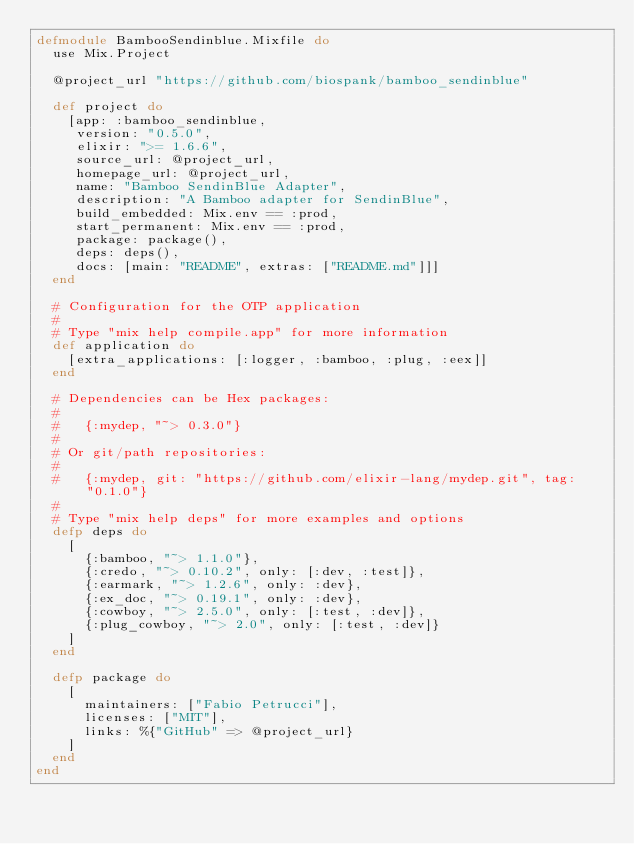Convert code to text. <code><loc_0><loc_0><loc_500><loc_500><_Elixir_>defmodule BambooSendinblue.Mixfile do
  use Mix.Project

  @project_url "https://github.com/biospank/bamboo_sendinblue"

  def project do
    [app: :bamboo_sendinblue,
     version: "0.5.0",
     elixir: ">= 1.6.6",
     source_url: @project_url,
     homepage_url: @project_url,
     name: "Bamboo SendinBlue Adapter",
     description: "A Bamboo adapter for SendinBlue",
     build_embedded: Mix.env == :prod,
     start_permanent: Mix.env == :prod,
     package: package(),
     deps: deps(),
     docs: [main: "README", extras: ["README.md"]]]
  end

  # Configuration for the OTP application
  #
  # Type "mix help compile.app" for more information
  def application do
    [extra_applications: [:logger, :bamboo, :plug, :eex]]
  end

  # Dependencies can be Hex packages:
  #
  #   {:mydep, "~> 0.3.0"}
  #
  # Or git/path repositories:
  #
  #   {:mydep, git: "https://github.com/elixir-lang/mydep.git", tag: "0.1.0"}
  #
  # Type "mix help deps" for more examples and options
  defp deps do
    [
      {:bamboo, "~> 1.1.0"},
      {:credo, "~> 0.10.2", only: [:dev, :test]},
      {:earmark, "~> 1.2.6", only: :dev},
      {:ex_doc, "~> 0.19.1", only: :dev},
      {:cowboy, "~> 2.5.0", only: [:test, :dev]},
      {:plug_cowboy, "~> 2.0", only: [:test, :dev]}
    ]
  end

  defp package do
    [
      maintainers: ["Fabio Petrucci"],
      licenses: ["MIT"],
      links: %{"GitHub" => @project_url}
    ]
  end
end
</code> 